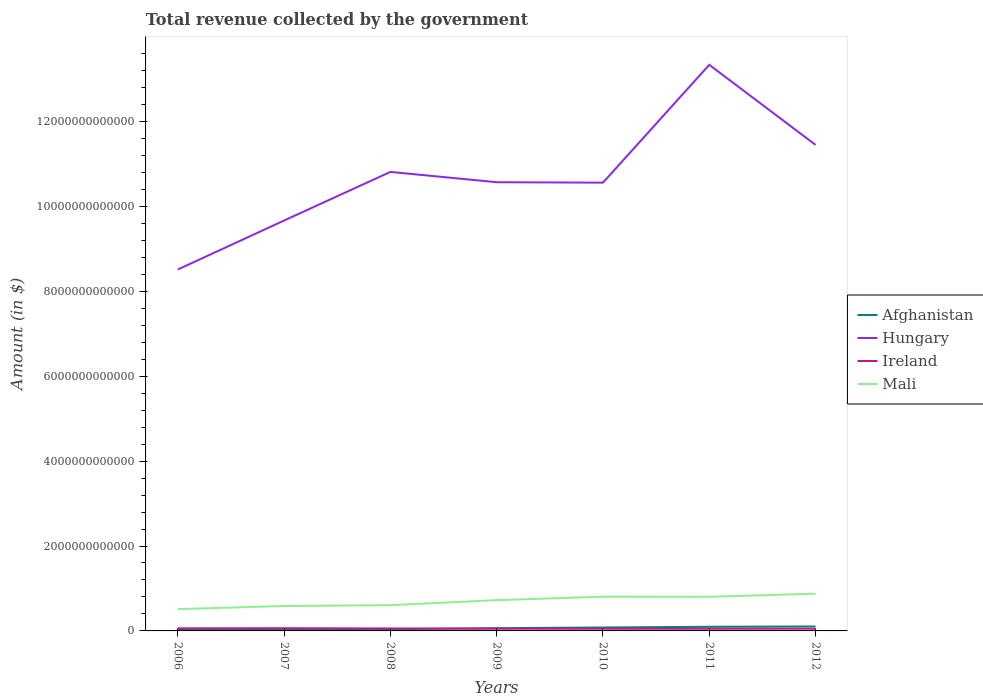How many different coloured lines are there?
Provide a succinct answer. 4. Does the line corresponding to Mali intersect with the line corresponding to Afghanistan?
Your response must be concise. No. Across all years, what is the maximum total revenue collected by the government in Hungary?
Your answer should be compact. 8.51e+12. In which year was the total revenue collected by the government in Afghanistan maximum?
Your answer should be very brief. 2006. What is the total total revenue collected by the government in Ireland in the graph?
Make the answer very short. 1.25e+1. What is the difference between the highest and the second highest total revenue collected by the government in Mali?
Give a very brief answer. 3.63e+11. What is the difference between the highest and the lowest total revenue collected by the government in Ireland?
Your answer should be very brief. 3. Is the total revenue collected by the government in Ireland strictly greater than the total revenue collected by the government in Hungary over the years?
Provide a short and direct response. Yes. How many years are there in the graph?
Give a very brief answer. 7. What is the difference between two consecutive major ticks on the Y-axis?
Offer a terse response. 2.00e+12. Does the graph contain grids?
Keep it short and to the point. No. How many legend labels are there?
Offer a terse response. 4. What is the title of the graph?
Ensure brevity in your answer.  Total revenue collected by the government. Does "Honduras" appear as one of the legend labels in the graph?
Offer a terse response. No. What is the label or title of the X-axis?
Your answer should be very brief. Years. What is the label or title of the Y-axis?
Your answer should be compact. Amount (in $). What is the Amount (in $) in Afghanistan in 2006?
Your answer should be compact. 3.12e+1. What is the Amount (in $) of Hungary in 2006?
Give a very brief answer. 8.51e+12. What is the Amount (in $) in Ireland in 2006?
Offer a very short reply. 6.09e+1. What is the Amount (in $) of Mali in 2006?
Offer a very short reply. 5.13e+11. What is the Amount (in $) of Afghanistan in 2007?
Provide a succinct answer. 3.40e+1. What is the Amount (in $) in Hungary in 2007?
Your answer should be compact. 9.67e+12. What is the Amount (in $) of Ireland in 2007?
Your response must be concise. 6.36e+1. What is the Amount (in $) in Mali in 2007?
Provide a short and direct response. 5.87e+11. What is the Amount (in $) of Afghanistan in 2008?
Ensure brevity in your answer.  4.15e+1. What is the Amount (in $) in Hungary in 2008?
Offer a terse response. 1.08e+13. What is the Amount (in $) of Ireland in 2008?
Provide a succinct answer. 5.81e+1. What is the Amount (in $) of Mali in 2008?
Make the answer very short. 6.07e+11. What is the Amount (in $) of Afghanistan in 2009?
Give a very brief answer. 6.47e+1. What is the Amount (in $) in Hungary in 2009?
Make the answer very short. 1.06e+13. What is the Amount (in $) in Ireland in 2009?
Provide a succinct answer. 5.15e+1. What is the Amount (in $) in Mali in 2009?
Offer a terse response. 7.25e+11. What is the Amount (in $) of Afghanistan in 2010?
Keep it short and to the point. 8.06e+1. What is the Amount (in $) in Hungary in 2010?
Ensure brevity in your answer.  1.06e+13. What is the Amount (in $) of Ireland in 2010?
Give a very brief answer. 5.09e+1. What is the Amount (in $) in Mali in 2010?
Ensure brevity in your answer.  8.06e+11. What is the Amount (in $) of Afghanistan in 2011?
Keep it short and to the point. 9.79e+1. What is the Amount (in $) in Hungary in 2011?
Provide a succinct answer. 1.33e+13. What is the Amount (in $) in Ireland in 2011?
Provide a succinct answer. 5.11e+1. What is the Amount (in $) of Mali in 2011?
Provide a succinct answer. 8.05e+11. What is the Amount (in $) in Afghanistan in 2012?
Give a very brief answer. 1.05e+11. What is the Amount (in $) of Hungary in 2012?
Provide a succinct answer. 1.14e+13. What is the Amount (in $) of Ireland in 2012?
Provide a succinct answer. 5.25e+1. What is the Amount (in $) of Mali in 2012?
Your answer should be compact. 8.76e+11. Across all years, what is the maximum Amount (in $) of Afghanistan?
Provide a succinct answer. 1.05e+11. Across all years, what is the maximum Amount (in $) in Hungary?
Make the answer very short. 1.33e+13. Across all years, what is the maximum Amount (in $) of Ireland?
Provide a short and direct response. 6.36e+1. Across all years, what is the maximum Amount (in $) of Mali?
Offer a very short reply. 8.76e+11. Across all years, what is the minimum Amount (in $) of Afghanistan?
Ensure brevity in your answer.  3.12e+1. Across all years, what is the minimum Amount (in $) of Hungary?
Offer a terse response. 8.51e+12. Across all years, what is the minimum Amount (in $) of Ireland?
Provide a succinct answer. 5.09e+1. Across all years, what is the minimum Amount (in $) in Mali?
Your answer should be compact. 5.13e+11. What is the total Amount (in $) of Afghanistan in the graph?
Make the answer very short. 4.55e+11. What is the total Amount (in $) of Hungary in the graph?
Your answer should be compact. 7.49e+13. What is the total Amount (in $) of Ireland in the graph?
Offer a terse response. 3.88e+11. What is the total Amount (in $) of Mali in the graph?
Provide a succinct answer. 4.92e+12. What is the difference between the Amount (in $) in Afghanistan in 2006 and that in 2007?
Provide a succinct answer. -2.81e+09. What is the difference between the Amount (in $) of Hungary in 2006 and that in 2007?
Your response must be concise. -1.15e+12. What is the difference between the Amount (in $) of Ireland in 2006 and that in 2007?
Keep it short and to the point. -2.70e+09. What is the difference between the Amount (in $) of Mali in 2006 and that in 2007?
Ensure brevity in your answer.  -7.39e+1. What is the difference between the Amount (in $) in Afghanistan in 2006 and that in 2008?
Make the answer very short. -1.03e+1. What is the difference between the Amount (in $) in Hungary in 2006 and that in 2008?
Make the answer very short. -2.30e+12. What is the difference between the Amount (in $) of Ireland in 2006 and that in 2008?
Your answer should be compact. 2.81e+09. What is the difference between the Amount (in $) in Mali in 2006 and that in 2008?
Your answer should be compact. -9.43e+1. What is the difference between the Amount (in $) of Afghanistan in 2006 and that in 2009?
Provide a short and direct response. -3.35e+1. What is the difference between the Amount (in $) of Hungary in 2006 and that in 2009?
Offer a terse response. -2.06e+12. What is the difference between the Amount (in $) of Ireland in 2006 and that in 2009?
Your response must be concise. 9.42e+09. What is the difference between the Amount (in $) of Mali in 2006 and that in 2009?
Keep it short and to the point. -2.12e+11. What is the difference between the Amount (in $) in Afghanistan in 2006 and that in 2010?
Your response must be concise. -4.93e+1. What is the difference between the Amount (in $) of Hungary in 2006 and that in 2010?
Offer a terse response. -2.05e+12. What is the difference between the Amount (in $) in Ireland in 2006 and that in 2010?
Give a very brief answer. 9.95e+09. What is the difference between the Amount (in $) in Mali in 2006 and that in 2010?
Give a very brief answer. -2.93e+11. What is the difference between the Amount (in $) of Afghanistan in 2006 and that in 2011?
Offer a terse response. -6.67e+1. What is the difference between the Amount (in $) of Hungary in 2006 and that in 2011?
Your response must be concise. -4.82e+12. What is the difference between the Amount (in $) in Ireland in 2006 and that in 2011?
Ensure brevity in your answer.  9.80e+09. What is the difference between the Amount (in $) of Mali in 2006 and that in 2011?
Provide a succinct answer. -2.92e+11. What is the difference between the Amount (in $) in Afghanistan in 2006 and that in 2012?
Ensure brevity in your answer.  -7.37e+1. What is the difference between the Amount (in $) in Hungary in 2006 and that in 2012?
Keep it short and to the point. -2.93e+12. What is the difference between the Amount (in $) in Ireland in 2006 and that in 2012?
Give a very brief answer. 8.35e+09. What is the difference between the Amount (in $) in Mali in 2006 and that in 2012?
Offer a terse response. -3.63e+11. What is the difference between the Amount (in $) of Afghanistan in 2007 and that in 2008?
Keep it short and to the point. -7.45e+09. What is the difference between the Amount (in $) in Hungary in 2007 and that in 2008?
Give a very brief answer. -1.15e+12. What is the difference between the Amount (in $) in Ireland in 2007 and that in 2008?
Your response must be concise. 5.51e+09. What is the difference between the Amount (in $) of Mali in 2007 and that in 2008?
Your answer should be very brief. -2.04e+1. What is the difference between the Amount (in $) in Afghanistan in 2007 and that in 2009?
Your response must be concise. -3.07e+1. What is the difference between the Amount (in $) in Hungary in 2007 and that in 2009?
Your answer should be very brief. -9.02e+11. What is the difference between the Amount (in $) in Ireland in 2007 and that in 2009?
Give a very brief answer. 1.21e+1. What is the difference between the Amount (in $) in Mali in 2007 and that in 2009?
Give a very brief answer. -1.38e+11. What is the difference between the Amount (in $) in Afghanistan in 2007 and that in 2010?
Make the answer very short. -4.65e+1. What is the difference between the Amount (in $) of Hungary in 2007 and that in 2010?
Give a very brief answer. -8.92e+11. What is the difference between the Amount (in $) in Ireland in 2007 and that in 2010?
Make the answer very short. 1.27e+1. What is the difference between the Amount (in $) of Mali in 2007 and that in 2010?
Give a very brief answer. -2.19e+11. What is the difference between the Amount (in $) in Afghanistan in 2007 and that in 2011?
Provide a short and direct response. -6.39e+1. What is the difference between the Amount (in $) of Hungary in 2007 and that in 2011?
Keep it short and to the point. -3.67e+12. What is the difference between the Amount (in $) in Ireland in 2007 and that in 2011?
Provide a succinct answer. 1.25e+1. What is the difference between the Amount (in $) of Mali in 2007 and that in 2011?
Provide a succinct answer. -2.18e+11. What is the difference between the Amount (in $) in Afghanistan in 2007 and that in 2012?
Your answer should be very brief. -7.09e+1. What is the difference between the Amount (in $) of Hungary in 2007 and that in 2012?
Your answer should be very brief. -1.78e+12. What is the difference between the Amount (in $) in Ireland in 2007 and that in 2012?
Offer a terse response. 1.10e+1. What is the difference between the Amount (in $) in Mali in 2007 and that in 2012?
Give a very brief answer. -2.89e+11. What is the difference between the Amount (in $) of Afghanistan in 2008 and that in 2009?
Provide a succinct answer. -2.32e+1. What is the difference between the Amount (in $) of Hungary in 2008 and that in 2009?
Your answer should be very brief. 2.43e+11. What is the difference between the Amount (in $) in Ireland in 2008 and that in 2009?
Your answer should be compact. 6.61e+09. What is the difference between the Amount (in $) in Mali in 2008 and that in 2009?
Your answer should be compact. -1.18e+11. What is the difference between the Amount (in $) of Afghanistan in 2008 and that in 2010?
Give a very brief answer. -3.91e+1. What is the difference between the Amount (in $) in Hungary in 2008 and that in 2010?
Ensure brevity in your answer.  2.53e+11. What is the difference between the Amount (in $) in Ireland in 2008 and that in 2010?
Give a very brief answer. 7.15e+09. What is the difference between the Amount (in $) of Mali in 2008 and that in 2010?
Provide a short and direct response. -1.99e+11. What is the difference between the Amount (in $) in Afghanistan in 2008 and that in 2011?
Your answer should be very brief. -5.64e+1. What is the difference between the Amount (in $) in Hungary in 2008 and that in 2011?
Provide a short and direct response. -2.52e+12. What is the difference between the Amount (in $) of Ireland in 2008 and that in 2011?
Make the answer very short. 7.00e+09. What is the difference between the Amount (in $) of Mali in 2008 and that in 2011?
Offer a terse response. -1.97e+11. What is the difference between the Amount (in $) of Afghanistan in 2008 and that in 2012?
Make the answer very short. -6.35e+1. What is the difference between the Amount (in $) of Hungary in 2008 and that in 2012?
Your answer should be compact. -6.36e+11. What is the difference between the Amount (in $) in Ireland in 2008 and that in 2012?
Your answer should be compact. 5.54e+09. What is the difference between the Amount (in $) in Mali in 2008 and that in 2012?
Offer a terse response. -2.69e+11. What is the difference between the Amount (in $) in Afghanistan in 2009 and that in 2010?
Ensure brevity in your answer.  -1.59e+1. What is the difference between the Amount (in $) in Hungary in 2009 and that in 2010?
Provide a succinct answer. 1.05e+1. What is the difference between the Amount (in $) of Ireland in 2009 and that in 2010?
Make the answer very short. 5.34e+08. What is the difference between the Amount (in $) in Mali in 2009 and that in 2010?
Offer a very short reply. -8.14e+1. What is the difference between the Amount (in $) in Afghanistan in 2009 and that in 2011?
Ensure brevity in your answer.  -3.32e+1. What is the difference between the Amount (in $) in Hungary in 2009 and that in 2011?
Make the answer very short. -2.77e+12. What is the difference between the Amount (in $) of Ireland in 2009 and that in 2011?
Give a very brief answer. 3.85e+08. What is the difference between the Amount (in $) of Mali in 2009 and that in 2011?
Provide a succinct answer. -7.96e+1. What is the difference between the Amount (in $) in Afghanistan in 2009 and that in 2012?
Give a very brief answer. -4.03e+1. What is the difference between the Amount (in $) of Hungary in 2009 and that in 2012?
Give a very brief answer. -8.79e+11. What is the difference between the Amount (in $) in Ireland in 2009 and that in 2012?
Provide a succinct answer. -1.07e+09. What is the difference between the Amount (in $) in Mali in 2009 and that in 2012?
Your response must be concise. -1.51e+11. What is the difference between the Amount (in $) in Afghanistan in 2010 and that in 2011?
Your response must be concise. -1.73e+1. What is the difference between the Amount (in $) of Hungary in 2010 and that in 2011?
Provide a succinct answer. -2.78e+12. What is the difference between the Amount (in $) of Ireland in 2010 and that in 2011?
Your answer should be very brief. -1.49e+08. What is the difference between the Amount (in $) of Mali in 2010 and that in 2011?
Provide a succinct answer. 1.80e+09. What is the difference between the Amount (in $) in Afghanistan in 2010 and that in 2012?
Offer a very short reply. -2.44e+1. What is the difference between the Amount (in $) in Hungary in 2010 and that in 2012?
Provide a succinct answer. -8.89e+11. What is the difference between the Amount (in $) in Ireland in 2010 and that in 2012?
Give a very brief answer. -1.60e+09. What is the difference between the Amount (in $) of Mali in 2010 and that in 2012?
Provide a short and direct response. -6.99e+1. What is the difference between the Amount (in $) of Afghanistan in 2011 and that in 2012?
Make the answer very short. -7.07e+09. What is the difference between the Amount (in $) of Hungary in 2011 and that in 2012?
Provide a short and direct response. 1.89e+12. What is the difference between the Amount (in $) of Ireland in 2011 and that in 2012?
Make the answer very short. -1.45e+09. What is the difference between the Amount (in $) in Mali in 2011 and that in 2012?
Your response must be concise. -7.17e+1. What is the difference between the Amount (in $) of Afghanistan in 2006 and the Amount (in $) of Hungary in 2007?
Offer a very short reply. -9.63e+12. What is the difference between the Amount (in $) of Afghanistan in 2006 and the Amount (in $) of Ireland in 2007?
Provide a succinct answer. -3.24e+1. What is the difference between the Amount (in $) in Afghanistan in 2006 and the Amount (in $) in Mali in 2007?
Provide a short and direct response. -5.56e+11. What is the difference between the Amount (in $) of Hungary in 2006 and the Amount (in $) of Ireland in 2007?
Provide a short and direct response. 8.45e+12. What is the difference between the Amount (in $) of Hungary in 2006 and the Amount (in $) of Mali in 2007?
Offer a terse response. 7.93e+12. What is the difference between the Amount (in $) in Ireland in 2006 and the Amount (in $) in Mali in 2007?
Keep it short and to the point. -5.26e+11. What is the difference between the Amount (in $) of Afghanistan in 2006 and the Amount (in $) of Hungary in 2008?
Provide a succinct answer. -1.08e+13. What is the difference between the Amount (in $) in Afghanistan in 2006 and the Amount (in $) in Ireland in 2008?
Your response must be concise. -2.69e+1. What is the difference between the Amount (in $) in Afghanistan in 2006 and the Amount (in $) in Mali in 2008?
Offer a terse response. -5.76e+11. What is the difference between the Amount (in $) in Hungary in 2006 and the Amount (in $) in Ireland in 2008?
Your answer should be very brief. 8.45e+12. What is the difference between the Amount (in $) of Hungary in 2006 and the Amount (in $) of Mali in 2008?
Your answer should be compact. 7.91e+12. What is the difference between the Amount (in $) in Ireland in 2006 and the Amount (in $) in Mali in 2008?
Your answer should be compact. -5.46e+11. What is the difference between the Amount (in $) in Afghanistan in 2006 and the Amount (in $) in Hungary in 2009?
Give a very brief answer. -1.05e+13. What is the difference between the Amount (in $) in Afghanistan in 2006 and the Amount (in $) in Ireland in 2009?
Ensure brevity in your answer.  -2.02e+1. What is the difference between the Amount (in $) in Afghanistan in 2006 and the Amount (in $) in Mali in 2009?
Provide a succinct answer. -6.94e+11. What is the difference between the Amount (in $) in Hungary in 2006 and the Amount (in $) in Ireland in 2009?
Provide a succinct answer. 8.46e+12. What is the difference between the Amount (in $) in Hungary in 2006 and the Amount (in $) in Mali in 2009?
Offer a terse response. 7.79e+12. What is the difference between the Amount (in $) of Ireland in 2006 and the Amount (in $) of Mali in 2009?
Keep it short and to the point. -6.64e+11. What is the difference between the Amount (in $) in Afghanistan in 2006 and the Amount (in $) in Hungary in 2010?
Ensure brevity in your answer.  -1.05e+13. What is the difference between the Amount (in $) in Afghanistan in 2006 and the Amount (in $) in Ireland in 2010?
Make the answer very short. -1.97e+1. What is the difference between the Amount (in $) in Afghanistan in 2006 and the Amount (in $) in Mali in 2010?
Ensure brevity in your answer.  -7.75e+11. What is the difference between the Amount (in $) in Hungary in 2006 and the Amount (in $) in Ireland in 2010?
Your response must be concise. 8.46e+12. What is the difference between the Amount (in $) in Hungary in 2006 and the Amount (in $) in Mali in 2010?
Provide a succinct answer. 7.71e+12. What is the difference between the Amount (in $) in Ireland in 2006 and the Amount (in $) in Mali in 2010?
Your answer should be very brief. -7.45e+11. What is the difference between the Amount (in $) in Afghanistan in 2006 and the Amount (in $) in Hungary in 2011?
Your answer should be compact. -1.33e+13. What is the difference between the Amount (in $) of Afghanistan in 2006 and the Amount (in $) of Ireland in 2011?
Provide a short and direct response. -1.99e+1. What is the difference between the Amount (in $) in Afghanistan in 2006 and the Amount (in $) in Mali in 2011?
Offer a very short reply. -7.73e+11. What is the difference between the Amount (in $) of Hungary in 2006 and the Amount (in $) of Ireland in 2011?
Ensure brevity in your answer.  8.46e+12. What is the difference between the Amount (in $) of Hungary in 2006 and the Amount (in $) of Mali in 2011?
Ensure brevity in your answer.  7.71e+12. What is the difference between the Amount (in $) of Ireland in 2006 and the Amount (in $) of Mali in 2011?
Give a very brief answer. -7.44e+11. What is the difference between the Amount (in $) in Afghanistan in 2006 and the Amount (in $) in Hungary in 2012?
Provide a short and direct response. -1.14e+13. What is the difference between the Amount (in $) of Afghanistan in 2006 and the Amount (in $) of Ireland in 2012?
Keep it short and to the point. -2.13e+1. What is the difference between the Amount (in $) of Afghanistan in 2006 and the Amount (in $) of Mali in 2012?
Your answer should be compact. -8.45e+11. What is the difference between the Amount (in $) in Hungary in 2006 and the Amount (in $) in Ireland in 2012?
Your answer should be compact. 8.46e+12. What is the difference between the Amount (in $) of Hungary in 2006 and the Amount (in $) of Mali in 2012?
Give a very brief answer. 7.64e+12. What is the difference between the Amount (in $) of Ireland in 2006 and the Amount (in $) of Mali in 2012?
Ensure brevity in your answer.  -8.15e+11. What is the difference between the Amount (in $) in Afghanistan in 2007 and the Amount (in $) in Hungary in 2008?
Offer a terse response. -1.08e+13. What is the difference between the Amount (in $) of Afghanistan in 2007 and the Amount (in $) of Ireland in 2008?
Provide a short and direct response. -2.40e+1. What is the difference between the Amount (in $) of Afghanistan in 2007 and the Amount (in $) of Mali in 2008?
Your response must be concise. -5.73e+11. What is the difference between the Amount (in $) of Hungary in 2007 and the Amount (in $) of Ireland in 2008?
Your response must be concise. 9.61e+12. What is the difference between the Amount (in $) of Hungary in 2007 and the Amount (in $) of Mali in 2008?
Give a very brief answer. 9.06e+12. What is the difference between the Amount (in $) in Ireland in 2007 and the Amount (in $) in Mali in 2008?
Offer a terse response. -5.44e+11. What is the difference between the Amount (in $) in Afghanistan in 2007 and the Amount (in $) in Hungary in 2009?
Offer a very short reply. -1.05e+13. What is the difference between the Amount (in $) in Afghanistan in 2007 and the Amount (in $) in Ireland in 2009?
Make the answer very short. -1.74e+1. What is the difference between the Amount (in $) of Afghanistan in 2007 and the Amount (in $) of Mali in 2009?
Your answer should be compact. -6.91e+11. What is the difference between the Amount (in $) of Hungary in 2007 and the Amount (in $) of Ireland in 2009?
Your answer should be very brief. 9.61e+12. What is the difference between the Amount (in $) of Hungary in 2007 and the Amount (in $) of Mali in 2009?
Your answer should be compact. 8.94e+12. What is the difference between the Amount (in $) in Ireland in 2007 and the Amount (in $) in Mali in 2009?
Offer a terse response. -6.61e+11. What is the difference between the Amount (in $) in Afghanistan in 2007 and the Amount (in $) in Hungary in 2010?
Provide a short and direct response. -1.05e+13. What is the difference between the Amount (in $) in Afghanistan in 2007 and the Amount (in $) in Ireland in 2010?
Make the answer very short. -1.69e+1. What is the difference between the Amount (in $) in Afghanistan in 2007 and the Amount (in $) in Mali in 2010?
Your response must be concise. -7.72e+11. What is the difference between the Amount (in $) of Hungary in 2007 and the Amount (in $) of Ireland in 2010?
Make the answer very short. 9.62e+12. What is the difference between the Amount (in $) in Hungary in 2007 and the Amount (in $) in Mali in 2010?
Keep it short and to the point. 8.86e+12. What is the difference between the Amount (in $) of Ireland in 2007 and the Amount (in $) of Mali in 2010?
Provide a succinct answer. -7.43e+11. What is the difference between the Amount (in $) of Afghanistan in 2007 and the Amount (in $) of Hungary in 2011?
Your answer should be very brief. -1.33e+13. What is the difference between the Amount (in $) in Afghanistan in 2007 and the Amount (in $) in Ireland in 2011?
Ensure brevity in your answer.  -1.70e+1. What is the difference between the Amount (in $) in Afghanistan in 2007 and the Amount (in $) in Mali in 2011?
Your answer should be compact. -7.71e+11. What is the difference between the Amount (in $) in Hungary in 2007 and the Amount (in $) in Ireland in 2011?
Give a very brief answer. 9.62e+12. What is the difference between the Amount (in $) in Hungary in 2007 and the Amount (in $) in Mali in 2011?
Provide a short and direct response. 8.86e+12. What is the difference between the Amount (in $) in Ireland in 2007 and the Amount (in $) in Mali in 2011?
Offer a very short reply. -7.41e+11. What is the difference between the Amount (in $) of Afghanistan in 2007 and the Amount (in $) of Hungary in 2012?
Your answer should be compact. -1.14e+13. What is the difference between the Amount (in $) in Afghanistan in 2007 and the Amount (in $) in Ireland in 2012?
Provide a succinct answer. -1.85e+1. What is the difference between the Amount (in $) in Afghanistan in 2007 and the Amount (in $) in Mali in 2012?
Provide a succinct answer. -8.42e+11. What is the difference between the Amount (in $) of Hungary in 2007 and the Amount (in $) of Ireland in 2012?
Your answer should be very brief. 9.61e+12. What is the difference between the Amount (in $) in Hungary in 2007 and the Amount (in $) in Mali in 2012?
Ensure brevity in your answer.  8.79e+12. What is the difference between the Amount (in $) in Ireland in 2007 and the Amount (in $) in Mali in 2012?
Your answer should be compact. -8.13e+11. What is the difference between the Amount (in $) in Afghanistan in 2008 and the Amount (in $) in Hungary in 2009?
Make the answer very short. -1.05e+13. What is the difference between the Amount (in $) of Afghanistan in 2008 and the Amount (in $) of Ireland in 2009?
Your response must be concise. -9.98e+09. What is the difference between the Amount (in $) in Afghanistan in 2008 and the Amount (in $) in Mali in 2009?
Give a very brief answer. -6.84e+11. What is the difference between the Amount (in $) in Hungary in 2008 and the Amount (in $) in Ireland in 2009?
Offer a very short reply. 1.08e+13. What is the difference between the Amount (in $) in Hungary in 2008 and the Amount (in $) in Mali in 2009?
Your answer should be very brief. 1.01e+13. What is the difference between the Amount (in $) in Ireland in 2008 and the Amount (in $) in Mali in 2009?
Provide a short and direct response. -6.67e+11. What is the difference between the Amount (in $) in Afghanistan in 2008 and the Amount (in $) in Hungary in 2010?
Offer a very short reply. -1.05e+13. What is the difference between the Amount (in $) of Afghanistan in 2008 and the Amount (in $) of Ireland in 2010?
Offer a terse response. -9.45e+09. What is the difference between the Amount (in $) of Afghanistan in 2008 and the Amount (in $) of Mali in 2010?
Keep it short and to the point. -7.65e+11. What is the difference between the Amount (in $) of Hungary in 2008 and the Amount (in $) of Ireland in 2010?
Provide a short and direct response. 1.08e+13. What is the difference between the Amount (in $) of Hungary in 2008 and the Amount (in $) of Mali in 2010?
Offer a very short reply. 1.00e+13. What is the difference between the Amount (in $) in Ireland in 2008 and the Amount (in $) in Mali in 2010?
Offer a terse response. -7.48e+11. What is the difference between the Amount (in $) of Afghanistan in 2008 and the Amount (in $) of Hungary in 2011?
Keep it short and to the point. -1.33e+13. What is the difference between the Amount (in $) in Afghanistan in 2008 and the Amount (in $) in Ireland in 2011?
Your response must be concise. -9.60e+09. What is the difference between the Amount (in $) in Afghanistan in 2008 and the Amount (in $) in Mali in 2011?
Give a very brief answer. -7.63e+11. What is the difference between the Amount (in $) in Hungary in 2008 and the Amount (in $) in Ireland in 2011?
Make the answer very short. 1.08e+13. What is the difference between the Amount (in $) of Hungary in 2008 and the Amount (in $) of Mali in 2011?
Your response must be concise. 1.00e+13. What is the difference between the Amount (in $) in Ireland in 2008 and the Amount (in $) in Mali in 2011?
Keep it short and to the point. -7.46e+11. What is the difference between the Amount (in $) in Afghanistan in 2008 and the Amount (in $) in Hungary in 2012?
Your answer should be compact. -1.14e+13. What is the difference between the Amount (in $) in Afghanistan in 2008 and the Amount (in $) in Ireland in 2012?
Provide a succinct answer. -1.11e+1. What is the difference between the Amount (in $) of Afghanistan in 2008 and the Amount (in $) of Mali in 2012?
Your response must be concise. -8.35e+11. What is the difference between the Amount (in $) in Hungary in 2008 and the Amount (in $) in Ireland in 2012?
Provide a succinct answer. 1.08e+13. What is the difference between the Amount (in $) in Hungary in 2008 and the Amount (in $) in Mali in 2012?
Offer a very short reply. 9.93e+12. What is the difference between the Amount (in $) in Ireland in 2008 and the Amount (in $) in Mali in 2012?
Offer a terse response. -8.18e+11. What is the difference between the Amount (in $) in Afghanistan in 2009 and the Amount (in $) in Hungary in 2010?
Offer a very short reply. -1.05e+13. What is the difference between the Amount (in $) in Afghanistan in 2009 and the Amount (in $) in Ireland in 2010?
Make the answer very short. 1.38e+1. What is the difference between the Amount (in $) of Afghanistan in 2009 and the Amount (in $) of Mali in 2010?
Ensure brevity in your answer.  -7.42e+11. What is the difference between the Amount (in $) of Hungary in 2009 and the Amount (in $) of Ireland in 2010?
Your answer should be compact. 1.05e+13. What is the difference between the Amount (in $) of Hungary in 2009 and the Amount (in $) of Mali in 2010?
Offer a terse response. 9.76e+12. What is the difference between the Amount (in $) in Ireland in 2009 and the Amount (in $) in Mali in 2010?
Make the answer very short. -7.55e+11. What is the difference between the Amount (in $) in Afghanistan in 2009 and the Amount (in $) in Hungary in 2011?
Your answer should be compact. -1.33e+13. What is the difference between the Amount (in $) of Afghanistan in 2009 and the Amount (in $) of Ireland in 2011?
Provide a succinct answer. 1.36e+1. What is the difference between the Amount (in $) of Afghanistan in 2009 and the Amount (in $) of Mali in 2011?
Provide a succinct answer. -7.40e+11. What is the difference between the Amount (in $) in Hungary in 2009 and the Amount (in $) in Ireland in 2011?
Your answer should be very brief. 1.05e+13. What is the difference between the Amount (in $) in Hungary in 2009 and the Amount (in $) in Mali in 2011?
Provide a succinct answer. 9.76e+12. What is the difference between the Amount (in $) in Ireland in 2009 and the Amount (in $) in Mali in 2011?
Keep it short and to the point. -7.53e+11. What is the difference between the Amount (in $) of Afghanistan in 2009 and the Amount (in $) of Hungary in 2012?
Ensure brevity in your answer.  -1.14e+13. What is the difference between the Amount (in $) in Afghanistan in 2009 and the Amount (in $) in Ireland in 2012?
Ensure brevity in your answer.  1.22e+1. What is the difference between the Amount (in $) in Afghanistan in 2009 and the Amount (in $) in Mali in 2012?
Provide a succinct answer. -8.12e+11. What is the difference between the Amount (in $) in Hungary in 2009 and the Amount (in $) in Ireland in 2012?
Provide a short and direct response. 1.05e+13. What is the difference between the Amount (in $) of Hungary in 2009 and the Amount (in $) of Mali in 2012?
Your answer should be compact. 9.69e+12. What is the difference between the Amount (in $) in Ireland in 2009 and the Amount (in $) in Mali in 2012?
Make the answer very short. -8.25e+11. What is the difference between the Amount (in $) of Afghanistan in 2010 and the Amount (in $) of Hungary in 2011?
Your answer should be compact. -1.33e+13. What is the difference between the Amount (in $) in Afghanistan in 2010 and the Amount (in $) in Ireland in 2011?
Offer a very short reply. 2.95e+1. What is the difference between the Amount (in $) of Afghanistan in 2010 and the Amount (in $) of Mali in 2011?
Provide a short and direct response. -7.24e+11. What is the difference between the Amount (in $) in Hungary in 2010 and the Amount (in $) in Ireland in 2011?
Keep it short and to the point. 1.05e+13. What is the difference between the Amount (in $) of Hungary in 2010 and the Amount (in $) of Mali in 2011?
Provide a succinct answer. 9.75e+12. What is the difference between the Amount (in $) of Ireland in 2010 and the Amount (in $) of Mali in 2011?
Make the answer very short. -7.54e+11. What is the difference between the Amount (in $) in Afghanistan in 2010 and the Amount (in $) in Hungary in 2012?
Give a very brief answer. -1.14e+13. What is the difference between the Amount (in $) of Afghanistan in 2010 and the Amount (in $) of Ireland in 2012?
Keep it short and to the point. 2.80e+1. What is the difference between the Amount (in $) of Afghanistan in 2010 and the Amount (in $) of Mali in 2012?
Your answer should be compact. -7.96e+11. What is the difference between the Amount (in $) in Hungary in 2010 and the Amount (in $) in Ireland in 2012?
Ensure brevity in your answer.  1.05e+13. What is the difference between the Amount (in $) of Hungary in 2010 and the Amount (in $) of Mali in 2012?
Provide a succinct answer. 9.68e+12. What is the difference between the Amount (in $) in Ireland in 2010 and the Amount (in $) in Mali in 2012?
Your answer should be very brief. -8.25e+11. What is the difference between the Amount (in $) in Afghanistan in 2011 and the Amount (in $) in Hungary in 2012?
Make the answer very short. -1.13e+13. What is the difference between the Amount (in $) in Afghanistan in 2011 and the Amount (in $) in Ireland in 2012?
Your response must be concise. 4.54e+1. What is the difference between the Amount (in $) of Afghanistan in 2011 and the Amount (in $) of Mali in 2012?
Offer a very short reply. -7.78e+11. What is the difference between the Amount (in $) in Hungary in 2011 and the Amount (in $) in Ireland in 2012?
Make the answer very short. 1.33e+13. What is the difference between the Amount (in $) of Hungary in 2011 and the Amount (in $) of Mali in 2012?
Ensure brevity in your answer.  1.25e+13. What is the difference between the Amount (in $) in Ireland in 2011 and the Amount (in $) in Mali in 2012?
Ensure brevity in your answer.  -8.25e+11. What is the average Amount (in $) of Afghanistan per year?
Your answer should be very brief. 6.50e+1. What is the average Amount (in $) in Hungary per year?
Make the answer very short. 1.07e+13. What is the average Amount (in $) of Ireland per year?
Provide a succinct answer. 5.55e+1. What is the average Amount (in $) in Mali per year?
Provide a succinct answer. 7.03e+11. In the year 2006, what is the difference between the Amount (in $) in Afghanistan and Amount (in $) in Hungary?
Your response must be concise. -8.48e+12. In the year 2006, what is the difference between the Amount (in $) of Afghanistan and Amount (in $) of Ireland?
Provide a succinct answer. -2.97e+1. In the year 2006, what is the difference between the Amount (in $) in Afghanistan and Amount (in $) in Mali?
Ensure brevity in your answer.  -4.82e+11. In the year 2006, what is the difference between the Amount (in $) in Hungary and Amount (in $) in Ireland?
Offer a very short reply. 8.45e+12. In the year 2006, what is the difference between the Amount (in $) of Hungary and Amount (in $) of Mali?
Give a very brief answer. 8.00e+12. In the year 2006, what is the difference between the Amount (in $) of Ireland and Amount (in $) of Mali?
Keep it short and to the point. -4.52e+11. In the year 2007, what is the difference between the Amount (in $) in Afghanistan and Amount (in $) in Hungary?
Provide a succinct answer. -9.63e+12. In the year 2007, what is the difference between the Amount (in $) in Afghanistan and Amount (in $) in Ireland?
Provide a succinct answer. -2.96e+1. In the year 2007, what is the difference between the Amount (in $) of Afghanistan and Amount (in $) of Mali?
Keep it short and to the point. -5.53e+11. In the year 2007, what is the difference between the Amount (in $) in Hungary and Amount (in $) in Ireland?
Your answer should be compact. 9.60e+12. In the year 2007, what is the difference between the Amount (in $) in Hungary and Amount (in $) in Mali?
Give a very brief answer. 9.08e+12. In the year 2007, what is the difference between the Amount (in $) in Ireland and Amount (in $) in Mali?
Your answer should be compact. -5.23e+11. In the year 2008, what is the difference between the Amount (in $) in Afghanistan and Amount (in $) in Hungary?
Your answer should be compact. -1.08e+13. In the year 2008, what is the difference between the Amount (in $) in Afghanistan and Amount (in $) in Ireland?
Your response must be concise. -1.66e+1. In the year 2008, what is the difference between the Amount (in $) in Afghanistan and Amount (in $) in Mali?
Make the answer very short. -5.66e+11. In the year 2008, what is the difference between the Amount (in $) in Hungary and Amount (in $) in Ireland?
Your answer should be compact. 1.08e+13. In the year 2008, what is the difference between the Amount (in $) in Hungary and Amount (in $) in Mali?
Your answer should be very brief. 1.02e+13. In the year 2008, what is the difference between the Amount (in $) in Ireland and Amount (in $) in Mali?
Make the answer very short. -5.49e+11. In the year 2009, what is the difference between the Amount (in $) in Afghanistan and Amount (in $) in Hungary?
Ensure brevity in your answer.  -1.05e+13. In the year 2009, what is the difference between the Amount (in $) of Afghanistan and Amount (in $) of Ireland?
Offer a very short reply. 1.32e+1. In the year 2009, what is the difference between the Amount (in $) in Afghanistan and Amount (in $) in Mali?
Your response must be concise. -6.60e+11. In the year 2009, what is the difference between the Amount (in $) of Hungary and Amount (in $) of Ireland?
Keep it short and to the point. 1.05e+13. In the year 2009, what is the difference between the Amount (in $) of Hungary and Amount (in $) of Mali?
Offer a very short reply. 9.84e+12. In the year 2009, what is the difference between the Amount (in $) in Ireland and Amount (in $) in Mali?
Provide a succinct answer. -6.74e+11. In the year 2010, what is the difference between the Amount (in $) in Afghanistan and Amount (in $) in Hungary?
Offer a very short reply. -1.05e+13. In the year 2010, what is the difference between the Amount (in $) of Afghanistan and Amount (in $) of Ireland?
Ensure brevity in your answer.  2.96e+1. In the year 2010, what is the difference between the Amount (in $) of Afghanistan and Amount (in $) of Mali?
Ensure brevity in your answer.  -7.26e+11. In the year 2010, what is the difference between the Amount (in $) in Hungary and Amount (in $) in Ireland?
Your response must be concise. 1.05e+13. In the year 2010, what is the difference between the Amount (in $) in Hungary and Amount (in $) in Mali?
Provide a short and direct response. 9.75e+12. In the year 2010, what is the difference between the Amount (in $) of Ireland and Amount (in $) of Mali?
Make the answer very short. -7.55e+11. In the year 2011, what is the difference between the Amount (in $) in Afghanistan and Amount (in $) in Hungary?
Ensure brevity in your answer.  -1.32e+13. In the year 2011, what is the difference between the Amount (in $) in Afghanistan and Amount (in $) in Ireland?
Keep it short and to the point. 4.68e+1. In the year 2011, what is the difference between the Amount (in $) in Afghanistan and Amount (in $) in Mali?
Your answer should be very brief. -7.07e+11. In the year 2011, what is the difference between the Amount (in $) in Hungary and Amount (in $) in Ireland?
Offer a very short reply. 1.33e+13. In the year 2011, what is the difference between the Amount (in $) of Hungary and Amount (in $) of Mali?
Your response must be concise. 1.25e+13. In the year 2011, what is the difference between the Amount (in $) in Ireland and Amount (in $) in Mali?
Your answer should be compact. -7.53e+11. In the year 2012, what is the difference between the Amount (in $) of Afghanistan and Amount (in $) of Hungary?
Your answer should be very brief. -1.13e+13. In the year 2012, what is the difference between the Amount (in $) of Afghanistan and Amount (in $) of Ireland?
Make the answer very short. 5.24e+1. In the year 2012, what is the difference between the Amount (in $) in Afghanistan and Amount (in $) in Mali?
Give a very brief answer. -7.71e+11. In the year 2012, what is the difference between the Amount (in $) of Hungary and Amount (in $) of Ireland?
Make the answer very short. 1.14e+13. In the year 2012, what is the difference between the Amount (in $) of Hungary and Amount (in $) of Mali?
Make the answer very short. 1.06e+13. In the year 2012, what is the difference between the Amount (in $) in Ireland and Amount (in $) in Mali?
Offer a very short reply. -8.24e+11. What is the ratio of the Amount (in $) of Afghanistan in 2006 to that in 2007?
Provide a short and direct response. 0.92. What is the ratio of the Amount (in $) of Hungary in 2006 to that in 2007?
Make the answer very short. 0.88. What is the ratio of the Amount (in $) of Ireland in 2006 to that in 2007?
Your response must be concise. 0.96. What is the ratio of the Amount (in $) of Mali in 2006 to that in 2007?
Provide a short and direct response. 0.87. What is the ratio of the Amount (in $) of Afghanistan in 2006 to that in 2008?
Offer a terse response. 0.75. What is the ratio of the Amount (in $) of Hungary in 2006 to that in 2008?
Provide a short and direct response. 0.79. What is the ratio of the Amount (in $) in Ireland in 2006 to that in 2008?
Give a very brief answer. 1.05. What is the ratio of the Amount (in $) of Mali in 2006 to that in 2008?
Your answer should be compact. 0.84. What is the ratio of the Amount (in $) in Afghanistan in 2006 to that in 2009?
Offer a terse response. 0.48. What is the ratio of the Amount (in $) in Hungary in 2006 to that in 2009?
Keep it short and to the point. 0.81. What is the ratio of the Amount (in $) of Ireland in 2006 to that in 2009?
Keep it short and to the point. 1.18. What is the ratio of the Amount (in $) of Mali in 2006 to that in 2009?
Provide a short and direct response. 0.71. What is the ratio of the Amount (in $) in Afghanistan in 2006 to that in 2010?
Keep it short and to the point. 0.39. What is the ratio of the Amount (in $) of Hungary in 2006 to that in 2010?
Provide a succinct answer. 0.81. What is the ratio of the Amount (in $) of Ireland in 2006 to that in 2010?
Your answer should be very brief. 1.2. What is the ratio of the Amount (in $) of Mali in 2006 to that in 2010?
Provide a short and direct response. 0.64. What is the ratio of the Amount (in $) in Afghanistan in 2006 to that in 2011?
Your response must be concise. 0.32. What is the ratio of the Amount (in $) in Hungary in 2006 to that in 2011?
Your answer should be compact. 0.64. What is the ratio of the Amount (in $) of Ireland in 2006 to that in 2011?
Provide a succinct answer. 1.19. What is the ratio of the Amount (in $) of Mali in 2006 to that in 2011?
Provide a short and direct response. 0.64. What is the ratio of the Amount (in $) of Afghanistan in 2006 to that in 2012?
Provide a succinct answer. 0.3. What is the ratio of the Amount (in $) in Hungary in 2006 to that in 2012?
Make the answer very short. 0.74. What is the ratio of the Amount (in $) of Ireland in 2006 to that in 2012?
Keep it short and to the point. 1.16. What is the ratio of the Amount (in $) in Mali in 2006 to that in 2012?
Offer a very short reply. 0.59. What is the ratio of the Amount (in $) in Afghanistan in 2007 to that in 2008?
Ensure brevity in your answer.  0.82. What is the ratio of the Amount (in $) of Hungary in 2007 to that in 2008?
Make the answer very short. 0.89. What is the ratio of the Amount (in $) of Ireland in 2007 to that in 2008?
Keep it short and to the point. 1.09. What is the ratio of the Amount (in $) in Mali in 2007 to that in 2008?
Provide a succinct answer. 0.97. What is the ratio of the Amount (in $) of Afghanistan in 2007 to that in 2009?
Keep it short and to the point. 0.53. What is the ratio of the Amount (in $) of Hungary in 2007 to that in 2009?
Offer a terse response. 0.91. What is the ratio of the Amount (in $) of Ireland in 2007 to that in 2009?
Your answer should be compact. 1.24. What is the ratio of the Amount (in $) of Mali in 2007 to that in 2009?
Your answer should be very brief. 0.81. What is the ratio of the Amount (in $) in Afghanistan in 2007 to that in 2010?
Your answer should be compact. 0.42. What is the ratio of the Amount (in $) in Hungary in 2007 to that in 2010?
Your response must be concise. 0.92. What is the ratio of the Amount (in $) in Ireland in 2007 to that in 2010?
Offer a very short reply. 1.25. What is the ratio of the Amount (in $) of Mali in 2007 to that in 2010?
Offer a very short reply. 0.73. What is the ratio of the Amount (in $) in Afghanistan in 2007 to that in 2011?
Provide a short and direct response. 0.35. What is the ratio of the Amount (in $) in Hungary in 2007 to that in 2011?
Keep it short and to the point. 0.72. What is the ratio of the Amount (in $) of Ireland in 2007 to that in 2011?
Ensure brevity in your answer.  1.24. What is the ratio of the Amount (in $) of Mali in 2007 to that in 2011?
Make the answer very short. 0.73. What is the ratio of the Amount (in $) in Afghanistan in 2007 to that in 2012?
Keep it short and to the point. 0.32. What is the ratio of the Amount (in $) of Hungary in 2007 to that in 2012?
Provide a succinct answer. 0.84. What is the ratio of the Amount (in $) of Ireland in 2007 to that in 2012?
Ensure brevity in your answer.  1.21. What is the ratio of the Amount (in $) in Mali in 2007 to that in 2012?
Provide a succinct answer. 0.67. What is the ratio of the Amount (in $) in Afghanistan in 2008 to that in 2009?
Your response must be concise. 0.64. What is the ratio of the Amount (in $) in Hungary in 2008 to that in 2009?
Your response must be concise. 1.02. What is the ratio of the Amount (in $) of Ireland in 2008 to that in 2009?
Make the answer very short. 1.13. What is the ratio of the Amount (in $) of Mali in 2008 to that in 2009?
Your answer should be very brief. 0.84. What is the ratio of the Amount (in $) in Afghanistan in 2008 to that in 2010?
Make the answer very short. 0.51. What is the ratio of the Amount (in $) in Ireland in 2008 to that in 2010?
Provide a short and direct response. 1.14. What is the ratio of the Amount (in $) in Mali in 2008 to that in 2010?
Your answer should be compact. 0.75. What is the ratio of the Amount (in $) of Afghanistan in 2008 to that in 2011?
Give a very brief answer. 0.42. What is the ratio of the Amount (in $) of Hungary in 2008 to that in 2011?
Your answer should be very brief. 0.81. What is the ratio of the Amount (in $) of Ireland in 2008 to that in 2011?
Provide a short and direct response. 1.14. What is the ratio of the Amount (in $) in Mali in 2008 to that in 2011?
Your answer should be compact. 0.75. What is the ratio of the Amount (in $) of Afghanistan in 2008 to that in 2012?
Provide a succinct answer. 0.4. What is the ratio of the Amount (in $) in Hungary in 2008 to that in 2012?
Your answer should be compact. 0.94. What is the ratio of the Amount (in $) in Ireland in 2008 to that in 2012?
Provide a succinct answer. 1.11. What is the ratio of the Amount (in $) in Mali in 2008 to that in 2012?
Keep it short and to the point. 0.69. What is the ratio of the Amount (in $) in Afghanistan in 2009 to that in 2010?
Provide a short and direct response. 0.8. What is the ratio of the Amount (in $) in Ireland in 2009 to that in 2010?
Provide a short and direct response. 1.01. What is the ratio of the Amount (in $) in Mali in 2009 to that in 2010?
Ensure brevity in your answer.  0.9. What is the ratio of the Amount (in $) of Afghanistan in 2009 to that in 2011?
Your answer should be very brief. 0.66. What is the ratio of the Amount (in $) in Hungary in 2009 to that in 2011?
Provide a short and direct response. 0.79. What is the ratio of the Amount (in $) of Ireland in 2009 to that in 2011?
Offer a very short reply. 1.01. What is the ratio of the Amount (in $) of Mali in 2009 to that in 2011?
Ensure brevity in your answer.  0.9. What is the ratio of the Amount (in $) in Afghanistan in 2009 to that in 2012?
Give a very brief answer. 0.62. What is the ratio of the Amount (in $) in Hungary in 2009 to that in 2012?
Offer a very short reply. 0.92. What is the ratio of the Amount (in $) of Ireland in 2009 to that in 2012?
Provide a succinct answer. 0.98. What is the ratio of the Amount (in $) of Mali in 2009 to that in 2012?
Offer a very short reply. 0.83. What is the ratio of the Amount (in $) in Afghanistan in 2010 to that in 2011?
Offer a terse response. 0.82. What is the ratio of the Amount (in $) of Hungary in 2010 to that in 2011?
Keep it short and to the point. 0.79. What is the ratio of the Amount (in $) of Mali in 2010 to that in 2011?
Keep it short and to the point. 1. What is the ratio of the Amount (in $) of Afghanistan in 2010 to that in 2012?
Make the answer very short. 0.77. What is the ratio of the Amount (in $) of Hungary in 2010 to that in 2012?
Your answer should be compact. 0.92. What is the ratio of the Amount (in $) of Ireland in 2010 to that in 2012?
Your answer should be compact. 0.97. What is the ratio of the Amount (in $) in Mali in 2010 to that in 2012?
Ensure brevity in your answer.  0.92. What is the ratio of the Amount (in $) of Afghanistan in 2011 to that in 2012?
Provide a short and direct response. 0.93. What is the ratio of the Amount (in $) in Hungary in 2011 to that in 2012?
Make the answer very short. 1.16. What is the ratio of the Amount (in $) of Ireland in 2011 to that in 2012?
Make the answer very short. 0.97. What is the ratio of the Amount (in $) of Mali in 2011 to that in 2012?
Offer a terse response. 0.92. What is the difference between the highest and the second highest Amount (in $) in Afghanistan?
Your answer should be compact. 7.07e+09. What is the difference between the highest and the second highest Amount (in $) in Hungary?
Your response must be concise. 1.89e+12. What is the difference between the highest and the second highest Amount (in $) of Ireland?
Your response must be concise. 2.70e+09. What is the difference between the highest and the second highest Amount (in $) of Mali?
Offer a terse response. 6.99e+1. What is the difference between the highest and the lowest Amount (in $) in Afghanistan?
Provide a succinct answer. 7.37e+1. What is the difference between the highest and the lowest Amount (in $) in Hungary?
Offer a terse response. 4.82e+12. What is the difference between the highest and the lowest Amount (in $) of Ireland?
Give a very brief answer. 1.27e+1. What is the difference between the highest and the lowest Amount (in $) of Mali?
Provide a short and direct response. 3.63e+11. 